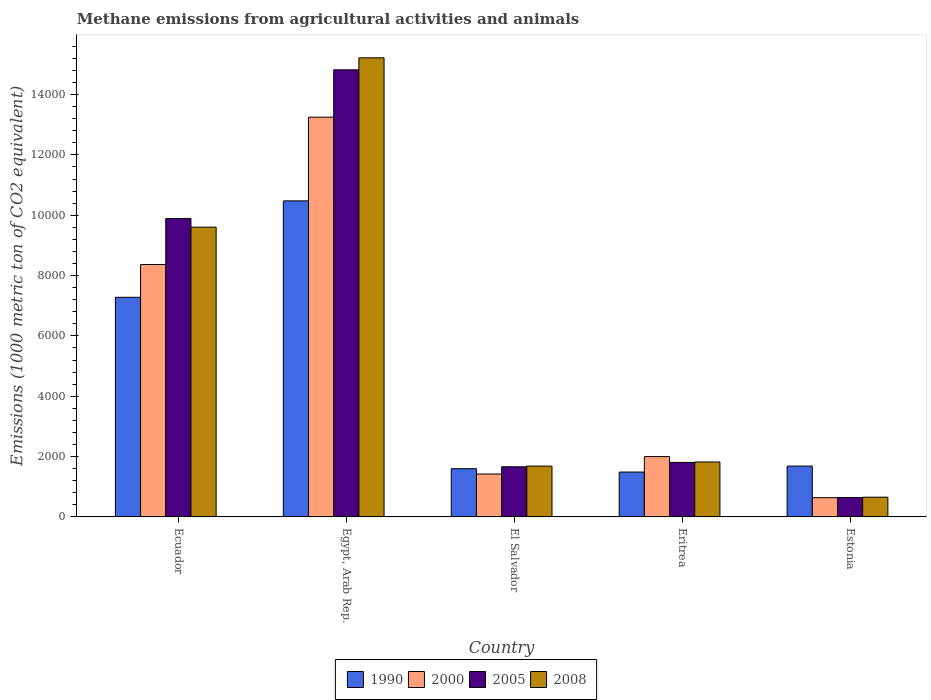How many different coloured bars are there?
Your answer should be very brief. 4. Are the number of bars per tick equal to the number of legend labels?
Your answer should be very brief. Yes. Are the number of bars on each tick of the X-axis equal?
Ensure brevity in your answer.  Yes. How many bars are there on the 5th tick from the left?
Provide a short and direct response. 4. How many bars are there on the 2nd tick from the right?
Offer a terse response. 4. What is the label of the 4th group of bars from the left?
Provide a short and direct response. Eritrea. In how many cases, is the number of bars for a given country not equal to the number of legend labels?
Offer a terse response. 0. What is the amount of methane emitted in 2005 in Estonia?
Make the answer very short. 642.9. Across all countries, what is the maximum amount of methane emitted in 2005?
Offer a very short reply. 1.48e+04. Across all countries, what is the minimum amount of methane emitted in 1990?
Keep it short and to the point. 1488.1. In which country was the amount of methane emitted in 2005 maximum?
Keep it short and to the point. Egypt, Arab Rep. In which country was the amount of methane emitted in 1990 minimum?
Keep it short and to the point. Eritrea. What is the total amount of methane emitted in 1990 in the graph?
Ensure brevity in your answer.  2.25e+04. What is the difference between the amount of methane emitted in 2005 in Egypt, Arab Rep. and that in Eritrea?
Your response must be concise. 1.30e+04. What is the difference between the amount of methane emitted in 2000 in Estonia and the amount of methane emitted in 1990 in El Salvador?
Provide a short and direct response. -961.6. What is the average amount of methane emitted in 2000 per country?
Keep it short and to the point. 5135.56. What is the difference between the amount of methane emitted of/in 2005 and amount of methane emitted of/in 1990 in Estonia?
Ensure brevity in your answer.  -1042.1. What is the ratio of the amount of methane emitted in 2005 in El Salvador to that in Estonia?
Offer a very short reply. 2.59. Is the amount of methane emitted in 1990 in Ecuador less than that in Estonia?
Provide a succinct answer. No. What is the difference between the highest and the second highest amount of methane emitted in 2000?
Provide a short and direct response. -1.13e+04. What is the difference between the highest and the lowest amount of methane emitted in 1990?
Offer a very short reply. 8988. In how many countries, is the amount of methane emitted in 2005 greater than the average amount of methane emitted in 2005 taken over all countries?
Make the answer very short. 2. Is it the case that in every country, the sum of the amount of methane emitted in 2000 and amount of methane emitted in 2005 is greater than the amount of methane emitted in 1990?
Offer a very short reply. No. How many countries are there in the graph?
Your response must be concise. 5. Are the values on the major ticks of Y-axis written in scientific E-notation?
Provide a succinct answer. No. Does the graph contain any zero values?
Offer a terse response. No. Does the graph contain grids?
Provide a short and direct response. No. How are the legend labels stacked?
Give a very brief answer. Horizontal. What is the title of the graph?
Your answer should be compact. Methane emissions from agricultural activities and animals. Does "1974" appear as one of the legend labels in the graph?
Ensure brevity in your answer.  No. What is the label or title of the X-axis?
Make the answer very short. Country. What is the label or title of the Y-axis?
Your response must be concise. Emissions (1000 metric ton of CO2 equivalent). What is the Emissions (1000 metric ton of CO2 equivalent) in 1990 in Ecuador?
Your answer should be very brief. 7280. What is the Emissions (1000 metric ton of CO2 equivalent) in 2000 in Ecuador?
Ensure brevity in your answer.  8366.7. What is the Emissions (1000 metric ton of CO2 equivalent) in 2005 in Ecuador?
Provide a succinct answer. 9891. What is the Emissions (1000 metric ton of CO2 equivalent) in 2008 in Ecuador?
Ensure brevity in your answer.  9604.8. What is the Emissions (1000 metric ton of CO2 equivalent) in 1990 in Egypt, Arab Rep.?
Make the answer very short. 1.05e+04. What is the Emissions (1000 metric ton of CO2 equivalent) in 2000 in Egypt, Arab Rep.?
Offer a very short reply. 1.33e+04. What is the Emissions (1000 metric ton of CO2 equivalent) of 2005 in Egypt, Arab Rep.?
Provide a succinct answer. 1.48e+04. What is the Emissions (1000 metric ton of CO2 equivalent) of 2008 in Egypt, Arab Rep.?
Provide a short and direct response. 1.52e+04. What is the Emissions (1000 metric ton of CO2 equivalent) of 1990 in El Salvador?
Offer a terse response. 1599.5. What is the Emissions (1000 metric ton of CO2 equivalent) in 2000 in El Salvador?
Provide a succinct answer. 1421.9. What is the Emissions (1000 metric ton of CO2 equivalent) in 2005 in El Salvador?
Your answer should be very brief. 1662.1. What is the Emissions (1000 metric ton of CO2 equivalent) in 2008 in El Salvador?
Your answer should be very brief. 1684.6. What is the Emissions (1000 metric ton of CO2 equivalent) of 1990 in Eritrea?
Give a very brief answer. 1488.1. What is the Emissions (1000 metric ton of CO2 equivalent) in 2000 in Eritrea?
Ensure brevity in your answer.  2000.3. What is the Emissions (1000 metric ton of CO2 equivalent) of 2005 in Eritrea?
Make the answer very short. 1806.6. What is the Emissions (1000 metric ton of CO2 equivalent) in 2008 in Eritrea?
Provide a short and direct response. 1820.8. What is the Emissions (1000 metric ton of CO2 equivalent) in 1990 in Estonia?
Ensure brevity in your answer.  1685. What is the Emissions (1000 metric ton of CO2 equivalent) in 2000 in Estonia?
Your answer should be compact. 637.9. What is the Emissions (1000 metric ton of CO2 equivalent) in 2005 in Estonia?
Your answer should be compact. 642.9. What is the Emissions (1000 metric ton of CO2 equivalent) in 2008 in Estonia?
Keep it short and to the point. 654. Across all countries, what is the maximum Emissions (1000 metric ton of CO2 equivalent) of 1990?
Offer a terse response. 1.05e+04. Across all countries, what is the maximum Emissions (1000 metric ton of CO2 equivalent) of 2000?
Offer a terse response. 1.33e+04. Across all countries, what is the maximum Emissions (1000 metric ton of CO2 equivalent) of 2005?
Offer a very short reply. 1.48e+04. Across all countries, what is the maximum Emissions (1000 metric ton of CO2 equivalent) in 2008?
Keep it short and to the point. 1.52e+04. Across all countries, what is the minimum Emissions (1000 metric ton of CO2 equivalent) of 1990?
Offer a terse response. 1488.1. Across all countries, what is the minimum Emissions (1000 metric ton of CO2 equivalent) of 2000?
Your response must be concise. 637.9. Across all countries, what is the minimum Emissions (1000 metric ton of CO2 equivalent) in 2005?
Make the answer very short. 642.9. Across all countries, what is the minimum Emissions (1000 metric ton of CO2 equivalent) of 2008?
Make the answer very short. 654. What is the total Emissions (1000 metric ton of CO2 equivalent) in 1990 in the graph?
Keep it short and to the point. 2.25e+04. What is the total Emissions (1000 metric ton of CO2 equivalent) in 2000 in the graph?
Your answer should be compact. 2.57e+04. What is the total Emissions (1000 metric ton of CO2 equivalent) in 2005 in the graph?
Give a very brief answer. 2.88e+04. What is the total Emissions (1000 metric ton of CO2 equivalent) of 2008 in the graph?
Give a very brief answer. 2.90e+04. What is the difference between the Emissions (1000 metric ton of CO2 equivalent) of 1990 in Ecuador and that in Egypt, Arab Rep.?
Your answer should be very brief. -3196.1. What is the difference between the Emissions (1000 metric ton of CO2 equivalent) of 2000 in Ecuador and that in Egypt, Arab Rep.?
Your answer should be very brief. -4884.3. What is the difference between the Emissions (1000 metric ton of CO2 equivalent) in 2005 in Ecuador and that in Egypt, Arab Rep.?
Your response must be concise. -4928.9. What is the difference between the Emissions (1000 metric ton of CO2 equivalent) in 2008 in Ecuador and that in Egypt, Arab Rep.?
Provide a short and direct response. -5612.4. What is the difference between the Emissions (1000 metric ton of CO2 equivalent) in 1990 in Ecuador and that in El Salvador?
Keep it short and to the point. 5680.5. What is the difference between the Emissions (1000 metric ton of CO2 equivalent) of 2000 in Ecuador and that in El Salvador?
Your answer should be compact. 6944.8. What is the difference between the Emissions (1000 metric ton of CO2 equivalent) of 2005 in Ecuador and that in El Salvador?
Keep it short and to the point. 8228.9. What is the difference between the Emissions (1000 metric ton of CO2 equivalent) in 2008 in Ecuador and that in El Salvador?
Your answer should be compact. 7920.2. What is the difference between the Emissions (1000 metric ton of CO2 equivalent) in 1990 in Ecuador and that in Eritrea?
Your answer should be very brief. 5791.9. What is the difference between the Emissions (1000 metric ton of CO2 equivalent) of 2000 in Ecuador and that in Eritrea?
Offer a very short reply. 6366.4. What is the difference between the Emissions (1000 metric ton of CO2 equivalent) in 2005 in Ecuador and that in Eritrea?
Your response must be concise. 8084.4. What is the difference between the Emissions (1000 metric ton of CO2 equivalent) in 2008 in Ecuador and that in Eritrea?
Provide a succinct answer. 7784. What is the difference between the Emissions (1000 metric ton of CO2 equivalent) in 1990 in Ecuador and that in Estonia?
Your answer should be very brief. 5595. What is the difference between the Emissions (1000 metric ton of CO2 equivalent) of 2000 in Ecuador and that in Estonia?
Make the answer very short. 7728.8. What is the difference between the Emissions (1000 metric ton of CO2 equivalent) of 2005 in Ecuador and that in Estonia?
Keep it short and to the point. 9248.1. What is the difference between the Emissions (1000 metric ton of CO2 equivalent) in 2008 in Ecuador and that in Estonia?
Ensure brevity in your answer.  8950.8. What is the difference between the Emissions (1000 metric ton of CO2 equivalent) of 1990 in Egypt, Arab Rep. and that in El Salvador?
Provide a succinct answer. 8876.6. What is the difference between the Emissions (1000 metric ton of CO2 equivalent) in 2000 in Egypt, Arab Rep. and that in El Salvador?
Your response must be concise. 1.18e+04. What is the difference between the Emissions (1000 metric ton of CO2 equivalent) in 2005 in Egypt, Arab Rep. and that in El Salvador?
Your response must be concise. 1.32e+04. What is the difference between the Emissions (1000 metric ton of CO2 equivalent) in 2008 in Egypt, Arab Rep. and that in El Salvador?
Your answer should be compact. 1.35e+04. What is the difference between the Emissions (1000 metric ton of CO2 equivalent) in 1990 in Egypt, Arab Rep. and that in Eritrea?
Ensure brevity in your answer.  8988. What is the difference between the Emissions (1000 metric ton of CO2 equivalent) of 2000 in Egypt, Arab Rep. and that in Eritrea?
Your response must be concise. 1.13e+04. What is the difference between the Emissions (1000 metric ton of CO2 equivalent) in 2005 in Egypt, Arab Rep. and that in Eritrea?
Your answer should be very brief. 1.30e+04. What is the difference between the Emissions (1000 metric ton of CO2 equivalent) in 2008 in Egypt, Arab Rep. and that in Eritrea?
Your response must be concise. 1.34e+04. What is the difference between the Emissions (1000 metric ton of CO2 equivalent) of 1990 in Egypt, Arab Rep. and that in Estonia?
Your answer should be very brief. 8791.1. What is the difference between the Emissions (1000 metric ton of CO2 equivalent) in 2000 in Egypt, Arab Rep. and that in Estonia?
Give a very brief answer. 1.26e+04. What is the difference between the Emissions (1000 metric ton of CO2 equivalent) of 2005 in Egypt, Arab Rep. and that in Estonia?
Provide a short and direct response. 1.42e+04. What is the difference between the Emissions (1000 metric ton of CO2 equivalent) in 2008 in Egypt, Arab Rep. and that in Estonia?
Provide a succinct answer. 1.46e+04. What is the difference between the Emissions (1000 metric ton of CO2 equivalent) in 1990 in El Salvador and that in Eritrea?
Provide a short and direct response. 111.4. What is the difference between the Emissions (1000 metric ton of CO2 equivalent) in 2000 in El Salvador and that in Eritrea?
Provide a short and direct response. -578.4. What is the difference between the Emissions (1000 metric ton of CO2 equivalent) in 2005 in El Salvador and that in Eritrea?
Your answer should be very brief. -144.5. What is the difference between the Emissions (1000 metric ton of CO2 equivalent) in 2008 in El Salvador and that in Eritrea?
Your answer should be compact. -136.2. What is the difference between the Emissions (1000 metric ton of CO2 equivalent) of 1990 in El Salvador and that in Estonia?
Provide a short and direct response. -85.5. What is the difference between the Emissions (1000 metric ton of CO2 equivalent) of 2000 in El Salvador and that in Estonia?
Give a very brief answer. 784. What is the difference between the Emissions (1000 metric ton of CO2 equivalent) in 2005 in El Salvador and that in Estonia?
Your answer should be compact. 1019.2. What is the difference between the Emissions (1000 metric ton of CO2 equivalent) in 2008 in El Salvador and that in Estonia?
Offer a terse response. 1030.6. What is the difference between the Emissions (1000 metric ton of CO2 equivalent) of 1990 in Eritrea and that in Estonia?
Offer a terse response. -196.9. What is the difference between the Emissions (1000 metric ton of CO2 equivalent) in 2000 in Eritrea and that in Estonia?
Offer a very short reply. 1362.4. What is the difference between the Emissions (1000 metric ton of CO2 equivalent) of 2005 in Eritrea and that in Estonia?
Make the answer very short. 1163.7. What is the difference between the Emissions (1000 metric ton of CO2 equivalent) of 2008 in Eritrea and that in Estonia?
Give a very brief answer. 1166.8. What is the difference between the Emissions (1000 metric ton of CO2 equivalent) in 1990 in Ecuador and the Emissions (1000 metric ton of CO2 equivalent) in 2000 in Egypt, Arab Rep.?
Your answer should be compact. -5971. What is the difference between the Emissions (1000 metric ton of CO2 equivalent) of 1990 in Ecuador and the Emissions (1000 metric ton of CO2 equivalent) of 2005 in Egypt, Arab Rep.?
Make the answer very short. -7539.9. What is the difference between the Emissions (1000 metric ton of CO2 equivalent) of 1990 in Ecuador and the Emissions (1000 metric ton of CO2 equivalent) of 2008 in Egypt, Arab Rep.?
Give a very brief answer. -7937.2. What is the difference between the Emissions (1000 metric ton of CO2 equivalent) in 2000 in Ecuador and the Emissions (1000 metric ton of CO2 equivalent) in 2005 in Egypt, Arab Rep.?
Ensure brevity in your answer.  -6453.2. What is the difference between the Emissions (1000 metric ton of CO2 equivalent) in 2000 in Ecuador and the Emissions (1000 metric ton of CO2 equivalent) in 2008 in Egypt, Arab Rep.?
Provide a short and direct response. -6850.5. What is the difference between the Emissions (1000 metric ton of CO2 equivalent) of 2005 in Ecuador and the Emissions (1000 metric ton of CO2 equivalent) of 2008 in Egypt, Arab Rep.?
Your response must be concise. -5326.2. What is the difference between the Emissions (1000 metric ton of CO2 equivalent) in 1990 in Ecuador and the Emissions (1000 metric ton of CO2 equivalent) in 2000 in El Salvador?
Provide a short and direct response. 5858.1. What is the difference between the Emissions (1000 metric ton of CO2 equivalent) in 1990 in Ecuador and the Emissions (1000 metric ton of CO2 equivalent) in 2005 in El Salvador?
Your answer should be compact. 5617.9. What is the difference between the Emissions (1000 metric ton of CO2 equivalent) of 1990 in Ecuador and the Emissions (1000 metric ton of CO2 equivalent) of 2008 in El Salvador?
Ensure brevity in your answer.  5595.4. What is the difference between the Emissions (1000 metric ton of CO2 equivalent) of 2000 in Ecuador and the Emissions (1000 metric ton of CO2 equivalent) of 2005 in El Salvador?
Provide a succinct answer. 6704.6. What is the difference between the Emissions (1000 metric ton of CO2 equivalent) in 2000 in Ecuador and the Emissions (1000 metric ton of CO2 equivalent) in 2008 in El Salvador?
Your answer should be compact. 6682.1. What is the difference between the Emissions (1000 metric ton of CO2 equivalent) of 2005 in Ecuador and the Emissions (1000 metric ton of CO2 equivalent) of 2008 in El Salvador?
Your answer should be compact. 8206.4. What is the difference between the Emissions (1000 metric ton of CO2 equivalent) of 1990 in Ecuador and the Emissions (1000 metric ton of CO2 equivalent) of 2000 in Eritrea?
Your response must be concise. 5279.7. What is the difference between the Emissions (1000 metric ton of CO2 equivalent) of 1990 in Ecuador and the Emissions (1000 metric ton of CO2 equivalent) of 2005 in Eritrea?
Your answer should be compact. 5473.4. What is the difference between the Emissions (1000 metric ton of CO2 equivalent) in 1990 in Ecuador and the Emissions (1000 metric ton of CO2 equivalent) in 2008 in Eritrea?
Offer a very short reply. 5459.2. What is the difference between the Emissions (1000 metric ton of CO2 equivalent) of 2000 in Ecuador and the Emissions (1000 metric ton of CO2 equivalent) of 2005 in Eritrea?
Your response must be concise. 6560.1. What is the difference between the Emissions (1000 metric ton of CO2 equivalent) of 2000 in Ecuador and the Emissions (1000 metric ton of CO2 equivalent) of 2008 in Eritrea?
Keep it short and to the point. 6545.9. What is the difference between the Emissions (1000 metric ton of CO2 equivalent) of 2005 in Ecuador and the Emissions (1000 metric ton of CO2 equivalent) of 2008 in Eritrea?
Your answer should be compact. 8070.2. What is the difference between the Emissions (1000 metric ton of CO2 equivalent) in 1990 in Ecuador and the Emissions (1000 metric ton of CO2 equivalent) in 2000 in Estonia?
Ensure brevity in your answer.  6642.1. What is the difference between the Emissions (1000 metric ton of CO2 equivalent) of 1990 in Ecuador and the Emissions (1000 metric ton of CO2 equivalent) of 2005 in Estonia?
Your answer should be very brief. 6637.1. What is the difference between the Emissions (1000 metric ton of CO2 equivalent) in 1990 in Ecuador and the Emissions (1000 metric ton of CO2 equivalent) in 2008 in Estonia?
Make the answer very short. 6626. What is the difference between the Emissions (1000 metric ton of CO2 equivalent) in 2000 in Ecuador and the Emissions (1000 metric ton of CO2 equivalent) in 2005 in Estonia?
Offer a very short reply. 7723.8. What is the difference between the Emissions (1000 metric ton of CO2 equivalent) in 2000 in Ecuador and the Emissions (1000 metric ton of CO2 equivalent) in 2008 in Estonia?
Your response must be concise. 7712.7. What is the difference between the Emissions (1000 metric ton of CO2 equivalent) in 2005 in Ecuador and the Emissions (1000 metric ton of CO2 equivalent) in 2008 in Estonia?
Ensure brevity in your answer.  9237. What is the difference between the Emissions (1000 metric ton of CO2 equivalent) of 1990 in Egypt, Arab Rep. and the Emissions (1000 metric ton of CO2 equivalent) of 2000 in El Salvador?
Provide a short and direct response. 9054.2. What is the difference between the Emissions (1000 metric ton of CO2 equivalent) of 1990 in Egypt, Arab Rep. and the Emissions (1000 metric ton of CO2 equivalent) of 2005 in El Salvador?
Offer a very short reply. 8814. What is the difference between the Emissions (1000 metric ton of CO2 equivalent) in 1990 in Egypt, Arab Rep. and the Emissions (1000 metric ton of CO2 equivalent) in 2008 in El Salvador?
Provide a short and direct response. 8791.5. What is the difference between the Emissions (1000 metric ton of CO2 equivalent) of 2000 in Egypt, Arab Rep. and the Emissions (1000 metric ton of CO2 equivalent) of 2005 in El Salvador?
Make the answer very short. 1.16e+04. What is the difference between the Emissions (1000 metric ton of CO2 equivalent) of 2000 in Egypt, Arab Rep. and the Emissions (1000 metric ton of CO2 equivalent) of 2008 in El Salvador?
Provide a short and direct response. 1.16e+04. What is the difference between the Emissions (1000 metric ton of CO2 equivalent) in 2005 in Egypt, Arab Rep. and the Emissions (1000 metric ton of CO2 equivalent) in 2008 in El Salvador?
Offer a very short reply. 1.31e+04. What is the difference between the Emissions (1000 metric ton of CO2 equivalent) of 1990 in Egypt, Arab Rep. and the Emissions (1000 metric ton of CO2 equivalent) of 2000 in Eritrea?
Keep it short and to the point. 8475.8. What is the difference between the Emissions (1000 metric ton of CO2 equivalent) of 1990 in Egypt, Arab Rep. and the Emissions (1000 metric ton of CO2 equivalent) of 2005 in Eritrea?
Offer a very short reply. 8669.5. What is the difference between the Emissions (1000 metric ton of CO2 equivalent) of 1990 in Egypt, Arab Rep. and the Emissions (1000 metric ton of CO2 equivalent) of 2008 in Eritrea?
Give a very brief answer. 8655.3. What is the difference between the Emissions (1000 metric ton of CO2 equivalent) of 2000 in Egypt, Arab Rep. and the Emissions (1000 metric ton of CO2 equivalent) of 2005 in Eritrea?
Provide a succinct answer. 1.14e+04. What is the difference between the Emissions (1000 metric ton of CO2 equivalent) of 2000 in Egypt, Arab Rep. and the Emissions (1000 metric ton of CO2 equivalent) of 2008 in Eritrea?
Your answer should be very brief. 1.14e+04. What is the difference between the Emissions (1000 metric ton of CO2 equivalent) of 2005 in Egypt, Arab Rep. and the Emissions (1000 metric ton of CO2 equivalent) of 2008 in Eritrea?
Your response must be concise. 1.30e+04. What is the difference between the Emissions (1000 metric ton of CO2 equivalent) of 1990 in Egypt, Arab Rep. and the Emissions (1000 metric ton of CO2 equivalent) of 2000 in Estonia?
Ensure brevity in your answer.  9838.2. What is the difference between the Emissions (1000 metric ton of CO2 equivalent) in 1990 in Egypt, Arab Rep. and the Emissions (1000 metric ton of CO2 equivalent) in 2005 in Estonia?
Keep it short and to the point. 9833.2. What is the difference between the Emissions (1000 metric ton of CO2 equivalent) in 1990 in Egypt, Arab Rep. and the Emissions (1000 metric ton of CO2 equivalent) in 2008 in Estonia?
Make the answer very short. 9822.1. What is the difference between the Emissions (1000 metric ton of CO2 equivalent) in 2000 in Egypt, Arab Rep. and the Emissions (1000 metric ton of CO2 equivalent) in 2005 in Estonia?
Your answer should be compact. 1.26e+04. What is the difference between the Emissions (1000 metric ton of CO2 equivalent) in 2000 in Egypt, Arab Rep. and the Emissions (1000 metric ton of CO2 equivalent) in 2008 in Estonia?
Offer a terse response. 1.26e+04. What is the difference between the Emissions (1000 metric ton of CO2 equivalent) of 2005 in Egypt, Arab Rep. and the Emissions (1000 metric ton of CO2 equivalent) of 2008 in Estonia?
Provide a succinct answer. 1.42e+04. What is the difference between the Emissions (1000 metric ton of CO2 equivalent) of 1990 in El Salvador and the Emissions (1000 metric ton of CO2 equivalent) of 2000 in Eritrea?
Provide a succinct answer. -400.8. What is the difference between the Emissions (1000 metric ton of CO2 equivalent) of 1990 in El Salvador and the Emissions (1000 metric ton of CO2 equivalent) of 2005 in Eritrea?
Offer a very short reply. -207.1. What is the difference between the Emissions (1000 metric ton of CO2 equivalent) of 1990 in El Salvador and the Emissions (1000 metric ton of CO2 equivalent) of 2008 in Eritrea?
Make the answer very short. -221.3. What is the difference between the Emissions (1000 metric ton of CO2 equivalent) in 2000 in El Salvador and the Emissions (1000 metric ton of CO2 equivalent) in 2005 in Eritrea?
Keep it short and to the point. -384.7. What is the difference between the Emissions (1000 metric ton of CO2 equivalent) of 2000 in El Salvador and the Emissions (1000 metric ton of CO2 equivalent) of 2008 in Eritrea?
Offer a terse response. -398.9. What is the difference between the Emissions (1000 metric ton of CO2 equivalent) of 2005 in El Salvador and the Emissions (1000 metric ton of CO2 equivalent) of 2008 in Eritrea?
Your response must be concise. -158.7. What is the difference between the Emissions (1000 metric ton of CO2 equivalent) of 1990 in El Salvador and the Emissions (1000 metric ton of CO2 equivalent) of 2000 in Estonia?
Ensure brevity in your answer.  961.6. What is the difference between the Emissions (1000 metric ton of CO2 equivalent) in 1990 in El Salvador and the Emissions (1000 metric ton of CO2 equivalent) in 2005 in Estonia?
Keep it short and to the point. 956.6. What is the difference between the Emissions (1000 metric ton of CO2 equivalent) in 1990 in El Salvador and the Emissions (1000 metric ton of CO2 equivalent) in 2008 in Estonia?
Provide a succinct answer. 945.5. What is the difference between the Emissions (1000 metric ton of CO2 equivalent) in 2000 in El Salvador and the Emissions (1000 metric ton of CO2 equivalent) in 2005 in Estonia?
Offer a very short reply. 779. What is the difference between the Emissions (1000 metric ton of CO2 equivalent) of 2000 in El Salvador and the Emissions (1000 metric ton of CO2 equivalent) of 2008 in Estonia?
Keep it short and to the point. 767.9. What is the difference between the Emissions (1000 metric ton of CO2 equivalent) of 2005 in El Salvador and the Emissions (1000 metric ton of CO2 equivalent) of 2008 in Estonia?
Offer a terse response. 1008.1. What is the difference between the Emissions (1000 metric ton of CO2 equivalent) of 1990 in Eritrea and the Emissions (1000 metric ton of CO2 equivalent) of 2000 in Estonia?
Provide a succinct answer. 850.2. What is the difference between the Emissions (1000 metric ton of CO2 equivalent) in 1990 in Eritrea and the Emissions (1000 metric ton of CO2 equivalent) in 2005 in Estonia?
Offer a very short reply. 845.2. What is the difference between the Emissions (1000 metric ton of CO2 equivalent) of 1990 in Eritrea and the Emissions (1000 metric ton of CO2 equivalent) of 2008 in Estonia?
Provide a short and direct response. 834.1. What is the difference between the Emissions (1000 metric ton of CO2 equivalent) of 2000 in Eritrea and the Emissions (1000 metric ton of CO2 equivalent) of 2005 in Estonia?
Provide a short and direct response. 1357.4. What is the difference between the Emissions (1000 metric ton of CO2 equivalent) of 2000 in Eritrea and the Emissions (1000 metric ton of CO2 equivalent) of 2008 in Estonia?
Your answer should be very brief. 1346.3. What is the difference between the Emissions (1000 metric ton of CO2 equivalent) in 2005 in Eritrea and the Emissions (1000 metric ton of CO2 equivalent) in 2008 in Estonia?
Ensure brevity in your answer.  1152.6. What is the average Emissions (1000 metric ton of CO2 equivalent) of 1990 per country?
Your answer should be very brief. 4505.74. What is the average Emissions (1000 metric ton of CO2 equivalent) of 2000 per country?
Provide a succinct answer. 5135.56. What is the average Emissions (1000 metric ton of CO2 equivalent) in 2005 per country?
Keep it short and to the point. 5764.5. What is the average Emissions (1000 metric ton of CO2 equivalent) in 2008 per country?
Provide a succinct answer. 5796.28. What is the difference between the Emissions (1000 metric ton of CO2 equivalent) in 1990 and Emissions (1000 metric ton of CO2 equivalent) in 2000 in Ecuador?
Your answer should be compact. -1086.7. What is the difference between the Emissions (1000 metric ton of CO2 equivalent) of 1990 and Emissions (1000 metric ton of CO2 equivalent) of 2005 in Ecuador?
Provide a short and direct response. -2611. What is the difference between the Emissions (1000 metric ton of CO2 equivalent) in 1990 and Emissions (1000 metric ton of CO2 equivalent) in 2008 in Ecuador?
Your answer should be compact. -2324.8. What is the difference between the Emissions (1000 metric ton of CO2 equivalent) of 2000 and Emissions (1000 metric ton of CO2 equivalent) of 2005 in Ecuador?
Offer a terse response. -1524.3. What is the difference between the Emissions (1000 metric ton of CO2 equivalent) in 2000 and Emissions (1000 metric ton of CO2 equivalent) in 2008 in Ecuador?
Give a very brief answer. -1238.1. What is the difference between the Emissions (1000 metric ton of CO2 equivalent) in 2005 and Emissions (1000 metric ton of CO2 equivalent) in 2008 in Ecuador?
Offer a terse response. 286.2. What is the difference between the Emissions (1000 metric ton of CO2 equivalent) of 1990 and Emissions (1000 metric ton of CO2 equivalent) of 2000 in Egypt, Arab Rep.?
Give a very brief answer. -2774.9. What is the difference between the Emissions (1000 metric ton of CO2 equivalent) in 1990 and Emissions (1000 metric ton of CO2 equivalent) in 2005 in Egypt, Arab Rep.?
Give a very brief answer. -4343.8. What is the difference between the Emissions (1000 metric ton of CO2 equivalent) of 1990 and Emissions (1000 metric ton of CO2 equivalent) of 2008 in Egypt, Arab Rep.?
Offer a terse response. -4741.1. What is the difference between the Emissions (1000 metric ton of CO2 equivalent) of 2000 and Emissions (1000 metric ton of CO2 equivalent) of 2005 in Egypt, Arab Rep.?
Your answer should be very brief. -1568.9. What is the difference between the Emissions (1000 metric ton of CO2 equivalent) of 2000 and Emissions (1000 metric ton of CO2 equivalent) of 2008 in Egypt, Arab Rep.?
Make the answer very short. -1966.2. What is the difference between the Emissions (1000 metric ton of CO2 equivalent) of 2005 and Emissions (1000 metric ton of CO2 equivalent) of 2008 in Egypt, Arab Rep.?
Provide a short and direct response. -397.3. What is the difference between the Emissions (1000 metric ton of CO2 equivalent) in 1990 and Emissions (1000 metric ton of CO2 equivalent) in 2000 in El Salvador?
Your response must be concise. 177.6. What is the difference between the Emissions (1000 metric ton of CO2 equivalent) of 1990 and Emissions (1000 metric ton of CO2 equivalent) of 2005 in El Salvador?
Your answer should be very brief. -62.6. What is the difference between the Emissions (1000 metric ton of CO2 equivalent) of 1990 and Emissions (1000 metric ton of CO2 equivalent) of 2008 in El Salvador?
Keep it short and to the point. -85.1. What is the difference between the Emissions (1000 metric ton of CO2 equivalent) of 2000 and Emissions (1000 metric ton of CO2 equivalent) of 2005 in El Salvador?
Provide a short and direct response. -240.2. What is the difference between the Emissions (1000 metric ton of CO2 equivalent) of 2000 and Emissions (1000 metric ton of CO2 equivalent) of 2008 in El Salvador?
Your response must be concise. -262.7. What is the difference between the Emissions (1000 metric ton of CO2 equivalent) in 2005 and Emissions (1000 metric ton of CO2 equivalent) in 2008 in El Salvador?
Keep it short and to the point. -22.5. What is the difference between the Emissions (1000 metric ton of CO2 equivalent) of 1990 and Emissions (1000 metric ton of CO2 equivalent) of 2000 in Eritrea?
Ensure brevity in your answer.  -512.2. What is the difference between the Emissions (1000 metric ton of CO2 equivalent) in 1990 and Emissions (1000 metric ton of CO2 equivalent) in 2005 in Eritrea?
Ensure brevity in your answer.  -318.5. What is the difference between the Emissions (1000 metric ton of CO2 equivalent) of 1990 and Emissions (1000 metric ton of CO2 equivalent) of 2008 in Eritrea?
Make the answer very short. -332.7. What is the difference between the Emissions (1000 metric ton of CO2 equivalent) of 2000 and Emissions (1000 metric ton of CO2 equivalent) of 2005 in Eritrea?
Give a very brief answer. 193.7. What is the difference between the Emissions (1000 metric ton of CO2 equivalent) in 2000 and Emissions (1000 metric ton of CO2 equivalent) in 2008 in Eritrea?
Offer a very short reply. 179.5. What is the difference between the Emissions (1000 metric ton of CO2 equivalent) of 1990 and Emissions (1000 metric ton of CO2 equivalent) of 2000 in Estonia?
Provide a succinct answer. 1047.1. What is the difference between the Emissions (1000 metric ton of CO2 equivalent) of 1990 and Emissions (1000 metric ton of CO2 equivalent) of 2005 in Estonia?
Your answer should be very brief. 1042.1. What is the difference between the Emissions (1000 metric ton of CO2 equivalent) of 1990 and Emissions (1000 metric ton of CO2 equivalent) of 2008 in Estonia?
Your answer should be compact. 1031. What is the difference between the Emissions (1000 metric ton of CO2 equivalent) of 2000 and Emissions (1000 metric ton of CO2 equivalent) of 2008 in Estonia?
Provide a succinct answer. -16.1. What is the ratio of the Emissions (1000 metric ton of CO2 equivalent) in 1990 in Ecuador to that in Egypt, Arab Rep.?
Keep it short and to the point. 0.69. What is the ratio of the Emissions (1000 metric ton of CO2 equivalent) of 2000 in Ecuador to that in Egypt, Arab Rep.?
Provide a short and direct response. 0.63. What is the ratio of the Emissions (1000 metric ton of CO2 equivalent) in 2005 in Ecuador to that in Egypt, Arab Rep.?
Provide a succinct answer. 0.67. What is the ratio of the Emissions (1000 metric ton of CO2 equivalent) of 2008 in Ecuador to that in Egypt, Arab Rep.?
Your response must be concise. 0.63. What is the ratio of the Emissions (1000 metric ton of CO2 equivalent) in 1990 in Ecuador to that in El Salvador?
Offer a very short reply. 4.55. What is the ratio of the Emissions (1000 metric ton of CO2 equivalent) of 2000 in Ecuador to that in El Salvador?
Your answer should be very brief. 5.88. What is the ratio of the Emissions (1000 metric ton of CO2 equivalent) in 2005 in Ecuador to that in El Salvador?
Provide a succinct answer. 5.95. What is the ratio of the Emissions (1000 metric ton of CO2 equivalent) of 2008 in Ecuador to that in El Salvador?
Your answer should be very brief. 5.7. What is the ratio of the Emissions (1000 metric ton of CO2 equivalent) in 1990 in Ecuador to that in Eritrea?
Give a very brief answer. 4.89. What is the ratio of the Emissions (1000 metric ton of CO2 equivalent) in 2000 in Ecuador to that in Eritrea?
Provide a short and direct response. 4.18. What is the ratio of the Emissions (1000 metric ton of CO2 equivalent) in 2005 in Ecuador to that in Eritrea?
Your answer should be compact. 5.47. What is the ratio of the Emissions (1000 metric ton of CO2 equivalent) in 2008 in Ecuador to that in Eritrea?
Ensure brevity in your answer.  5.28. What is the ratio of the Emissions (1000 metric ton of CO2 equivalent) of 1990 in Ecuador to that in Estonia?
Provide a succinct answer. 4.32. What is the ratio of the Emissions (1000 metric ton of CO2 equivalent) of 2000 in Ecuador to that in Estonia?
Your answer should be very brief. 13.12. What is the ratio of the Emissions (1000 metric ton of CO2 equivalent) of 2005 in Ecuador to that in Estonia?
Offer a very short reply. 15.38. What is the ratio of the Emissions (1000 metric ton of CO2 equivalent) in 2008 in Ecuador to that in Estonia?
Your response must be concise. 14.69. What is the ratio of the Emissions (1000 metric ton of CO2 equivalent) of 1990 in Egypt, Arab Rep. to that in El Salvador?
Offer a very short reply. 6.55. What is the ratio of the Emissions (1000 metric ton of CO2 equivalent) of 2000 in Egypt, Arab Rep. to that in El Salvador?
Offer a very short reply. 9.32. What is the ratio of the Emissions (1000 metric ton of CO2 equivalent) of 2005 in Egypt, Arab Rep. to that in El Salvador?
Your answer should be very brief. 8.92. What is the ratio of the Emissions (1000 metric ton of CO2 equivalent) in 2008 in Egypt, Arab Rep. to that in El Salvador?
Your answer should be compact. 9.03. What is the ratio of the Emissions (1000 metric ton of CO2 equivalent) of 1990 in Egypt, Arab Rep. to that in Eritrea?
Your answer should be compact. 7.04. What is the ratio of the Emissions (1000 metric ton of CO2 equivalent) of 2000 in Egypt, Arab Rep. to that in Eritrea?
Ensure brevity in your answer.  6.62. What is the ratio of the Emissions (1000 metric ton of CO2 equivalent) of 2005 in Egypt, Arab Rep. to that in Eritrea?
Provide a succinct answer. 8.2. What is the ratio of the Emissions (1000 metric ton of CO2 equivalent) of 2008 in Egypt, Arab Rep. to that in Eritrea?
Provide a short and direct response. 8.36. What is the ratio of the Emissions (1000 metric ton of CO2 equivalent) in 1990 in Egypt, Arab Rep. to that in Estonia?
Offer a terse response. 6.22. What is the ratio of the Emissions (1000 metric ton of CO2 equivalent) of 2000 in Egypt, Arab Rep. to that in Estonia?
Provide a succinct answer. 20.77. What is the ratio of the Emissions (1000 metric ton of CO2 equivalent) in 2005 in Egypt, Arab Rep. to that in Estonia?
Offer a very short reply. 23.05. What is the ratio of the Emissions (1000 metric ton of CO2 equivalent) of 2008 in Egypt, Arab Rep. to that in Estonia?
Make the answer very short. 23.27. What is the ratio of the Emissions (1000 metric ton of CO2 equivalent) in 1990 in El Salvador to that in Eritrea?
Provide a succinct answer. 1.07. What is the ratio of the Emissions (1000 metric ton of CO2 equivalent) in 2000 in El Salvador to that in Eritrea?
Your answer should be very brief. 0.71. What is the ratio of the Emissions (1000 metric ton of CO2 equivalent) of 2005 in El Salvador to that in Eritrea?
Provide a succinct answer. 0.92. What is the ratio of the Emissions (1000 metric ton of CO2 equivalent) of 2008 in El Salvador to that in Eritrea?
Keep it short and to the point. 0.93. What is the ratio of the Emissions (1000 metric ton of CO2 equivalent) of 1990 in El Salvador to that in Estonia?
Your response must be concise. 0.95. What is the ratio of the Emissions (1000 metric ton of CO2 equivalent) in 2000 in El Salvador to that in Estonia?
Provide a succinct answer. 2.23. What is the ratio of the Emissions (1000 metric ton of CO2 equivalent) of 2005 in El Salvador to that in Estonia?
Offer a very short reply. 2.59. What is the ratio of the Emissions (1000 metric ton of CO2 equivalent) in 2008 in El Salvador to that in Estonia?
Keep it short and to the point. 2.58. What is the ratio of the Emissions (1000 metric ton of CO2 equivalent) of 1990 in Eritrea to that in Estonia?
Ensure brevity in your answer.  0.88. What is the ratio of the Emissions (1000 metric ton of CO2 equivalent) in 2000 in Eritrea to that in Estonia?
Give a very brief answer. 3.14. What is the ratio of the Emissions (1000 metric ton of CO2 equivalent) in 2005 in Eritrea to that in Estonia?
Your answer should be very brief. 2.81. What is the ratio of the Emissions (1000 metric ton of CO2 equivalent) in 2008 in Eritrea to that in Estonia?
Make the answer very short. 2.78. What is the difference between the highest and the second highest Emissions (1000 metric ton of CO2 equivalent) of 1990?
Offer a terse response. 3196.1. What is the difference between the highest and the second highest Emissions (1000 metric ton of CO2 equivalent) in 2000?
Your answer should be very brief. 4884.3. What is the difference between the highest and the second highest Emissions (1000 metric ton of CO2 equivalent) of 2005?
Provide a succinct answer. 4928.9. What is the difference between the highest and the second highest Emissions (1000 metric ton of CO2 equivalent) of 2008?
Your response must be concise. 5612.4. What is the difference between the highest and the lowest Emissions (1000 metric ton of CO2 equivalent) in 1990?
Ensure brevity in your answer.  8988. What is the difference between the highest and the lowest Emissions (1000 metric ton of CO2 equivalent) of 2000?
Keep it short and to the point. 1.26e+04. What is the difference between the highest and the lowest Emissions (1000 metric ton of CO2 equivalent) in 2005?
Your response must be concise. 1.42e+04. What is the difference between the highest and the lowest Emissions (1000 metric ton of CO2 equivalent) of 2008?
Make the answer very short. 1.46e+04. 